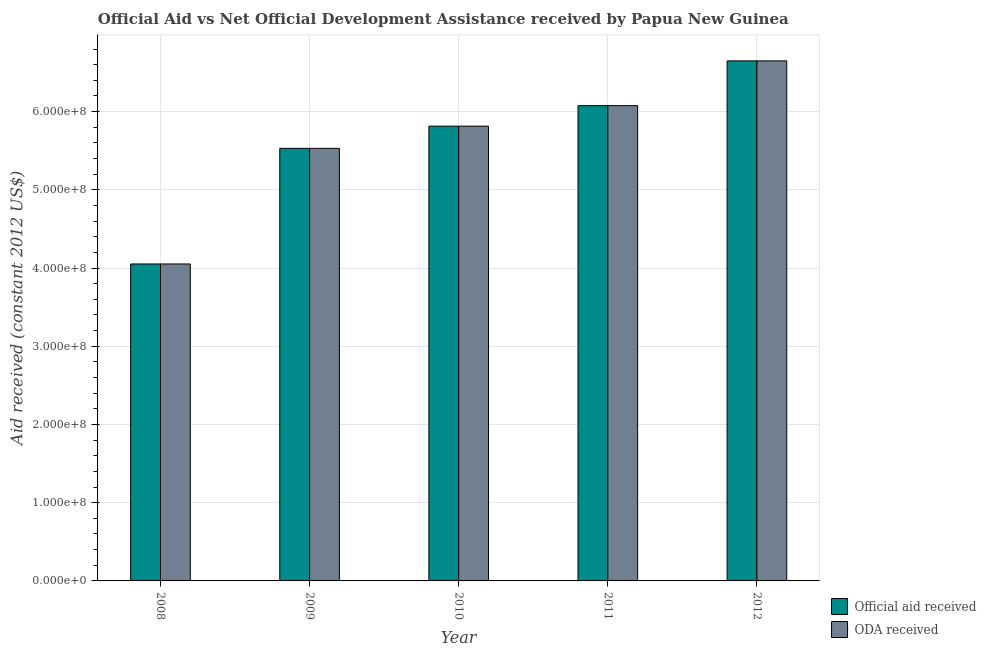Are the number of bars per tick equal to the number of legend labels?
Your answer should be very brief. Yes. Are the number of bars on each tick of the X-axis equal?
Provide a succinct answer. Yes. How many bars are there on the 1st tick from the left?
Your answer should be very brief. 2. How many bars are there on the 4th tick from the right?
Offer a very short reply. 2. What is the official aid received in 2008?
Give a very brief answer. 4.05e+08. Across all years, what is the maximum oda received?
Offer a terse response. 6.65e+08. Across all years, what is the minimum official aid received?
Make the answer very short. 4.05e+08. In which year was the oda received maximum?
Make the answer very short. 2012. What is the total official aid received in the graph?
Give a very brief answer. 2.81e+09. What is the difference between the oda received in 2008 and that in 2010?
Make the answer very short. -1.76e+08. What is the difference between the oda received in 2012 and the official aid received in 2009?
Provide a short and direct response. 1.12e+08. What is the average oda received per year?
Your response must be concise. 5.62e+08. In the year 2011, what is the difference between the oda received and official aid received?
Provide a short and direct response. 0. What is the ratio of the oda received in 2008 to that in 2009?
Provide a short and direct response. 0.73. Is the official aid received in 2009 less than that in 2010?
Give a very brief answer. Yes. Is the difference between the official aid received in 2008 and 2012 greater than the difference between the oda received in 2008 and 2012?
Offer a very short reply. No. What is the difference between the highest and the second highest official aid received?
Keep it short and to the point. 5.73e+07. What is the difference between the highest and the lowest oda received?
Offer a terse response. 2.60e+08. In how many years, is the oda received greater than the average oda received taken over all years?
Your answer should be very brief. 3. Is the sum of the official aid received in 2011 and 2012 greater than the maximum oda received across all years?
Ensure brevity in your answer.  Yes. What does the 2nd bar from the left in 2010 represents?
Offer a very short reply. ODA received. What does the 1st bar from the right in 2012 represents?
Make the answer very short. ODA received. Are all the bars in the graph horizontal?
Your answer should be compact. No. How many years are there in the graph?
Ensure brevity in your answer.  5. Are the values on the major ticks of Y-axis written in scientific E-notation?
Offer a terse response. Yes. Does the graph contain any zero values?
Make the answer very short. No. What is the title of the graph?
Your answer should be compact. Official Aid vs Net Official Development Assistance received by Papua New Guinea . What is the label or title of the Y-axis?
Your response must be concise. Aid received (constant 2012 US$). What is the Aid received (constant 2012 US$) of Official aid received in 2008?
Your answer should be compact. 4.05e+08. What is the Aid received (constant 2012 US$) in ODA received in 2008?
Offer a very short reply. 4.05e+08. What is the Aid received (constant 2012 US$) in Official aid received in 2009?
Your answer should be compact. 5.53e+08. What is the Aid received (constant 2012 US$) in ODA received in 2009?
Keep it short and to the point. 5.53e+08. What is the Aid received (constant 2012 US$) of Official aid received in 2010?
Your answer should be compact. 5.81e+08. What is the Aid received (constant 2012 US$) of ODA received in 2010?
Your response must be concise. 5.81e+08. What is the Aid received (constant 2012 US$) in Official aid received in 2011?
Your answer should be very brief. 6.08e+08. What is the Aid received (constant 2012 US$) of ODA received in 2011?
Your answer should be compact. 6.08e+08. What is the Aid received (constant 2012 US$) in Official aid received in 2012?
Ensure brevity in your answer.  6.65e+08. What is the Aid received (constant 2012 US$) of ODA received in 2012?
Keep it short and to the point. 6.65e+08. Across all years, what is the maximum Aid received (constant 2012 US$) in Official aid received?
Your answer should be compact. 6.65e+08. Across all years, what is the maximum Aid received (constant 2012 US$) of ODA received?
Give a very brief answer. 6.65e+08. Across all years, what is the minimum Aid received (constant 2012 US$) of Official aid received?
Provide a short and direct response. 4.05e+08. Across all years, what is the minimum Aid received (constant 2012 US$) in ODA received?
Ensure brevity in your answer.  4.05e+08. What is the total Aid received (constant 2012 US$) of Official aid received in the graph?
Ensure brevity in your answer.  2.81e+09. What is the total Aid received (constant 2012 US$) of ODA received in the graph?
Provide a short and direct response. 2.81e+09. What is the difference between the Aid received (constant 2012 US$) in Official aid received in 2008 and that in 2009?
Ensure brevity in your answer.  -1.48e+08. What is the difference between the Aid received (constant 2012 US$) of ODA received in 2008 and that in 2009?
Provide a succinct answer. -1.48e+08. What is the difference between the Aid received (constant 2012 US$) in Official aid received in 2008 and that in 2010?
Your answer should be very brief. -1.76e+08. What is the difference between the Aid received (constant 2012 US$) of ODA received in 2008 and that in 2010?
Keep it short and to the point. -1.76e+08. What is the difference between the Aid received (constant 2012 US$) in Official aid received in 2008 and that in 2011?
Ensure brevity in your answer.  -2.02e+08. What is the difference between the Aid received (constant 2012 US$) in ODA received in 2008 and that in 2011?
Provide a short and direct response. -2.02e+08. What is the difference between the Aid received (constant 2012 US$) of Official aid received in 2008 and that in 2012?
Make the answer very short. -2.60e+08. What is the difference between the Aid received (constant 2012 US$) in ODA received in 2008 and that in 2012?
Your answer should be compact. -2.60e+08. What is the difference between the Aid received (constant 2012 US$) of Official aid received in 2009 and that in 2010?
Offer a very short reply. -2.84e+07. What is the difference between the Aid received (constant 2012 US$) of ODA received in 2009 and that in 2010?
Provide a short and direct response. -2.84e+07. What is the difference between the Aid received (constant 2012 US$) of Official aid received in 2009 and that in 2011?
Offer a very short reply. -5.46e+07. What is the difference between the Aid received (constant 2012 US$) of ODA received in 2009 and that in 2011?
Ensure brevity in your answer.  -5.46e+07. What is the difference between the Aid received (constant 2012 US$) in Official aid received in 2009 and that in 2012?
Give a very brief answer. -1.12e+08. What is the difference between the Aid received (constant 2012 US$) in ODA received in 2009 and that in 2012?
Your response must be concise. -1.12e+08. What is the difference between the Aid received (constant 2012 US$) in Official aid received in 2010 and that in 2011?
Offer a very short reply. -2.62e+07. What is the difference between the Aid received (constant 2012 US$) of ODA received in 2010 and that in 2011?
Offer a terse response. -2.62e+07. What is the difference between the Aid received (constant 2012 US$) in Official aid received in 2010 and that in 2012?
Keep it short and to the point. -8.34e+07. What is the difference between the Aid received (constant 2012 US$) of ODA received in 2010 and that in 2012?
Your answer should be very brief. -8.34e+07. What is the difference between the Aid received (constant 2012 US$) of Official aid received in 2011 and that in 2012?
Offer a very short reply. -5.73e+07. What is the difference between the Aid received (constant 2012 US$) of ODA received in 2011 and that in 2012?
Give a very brief answer. -5.73e+07. What is the difference between the Aid received (constant 2012 US$) in Official aid received in 2008 and the Aid received (constant 2012 US$) in ODA received in 2009?
Keep it short and to the point. -1.48e+08. What is the difference between the Aid received (constant 2012 US$) in Official aid received in 2008 and the Aid received (constant 2012 US$) in ODA received in 2010?
Give a very brief answer. -1.76e+08. What is the difference between the Aid received (constant 2012 US$) in Official aid received in 2008 and the Aid received (constant 2012 US$) in ODA received in 2011?
Give a very brief answer. -2.02e+08. What is the difference between the Aid received (constant 2012 US$) in Official aid received in 2008 and the Aid received (constant 2012 US$) in ODA received in 2012?
Give a very brief answer. -2.60e+08. What is the difference between the Aid received (constant 2012 US$) in Official aid received in 2009 and the Aid received (constant 2012 US$) in ODA received in 2010?
Provide a succinct answer. -2.84e+07. What is the difference between the Aid received (constant 2012 US$) in Official aid received in 2009 and the Aid received (constant 2012 US$) in ODA received in 2011?
Keep it short and to the point. -5.46e+07. What is the difference between the Aid received (constant 2012 US$) of Official aid received in 2009 and the Aid received (constant 2012 US$) of ODA received in 2012?
Your answer should be very brief. -1.12e+08. What is the difference between the Aid received (constant 2012 US$) in Official aid received in 2010 and the Aid received (constant 2012 US$) in ODA received in 2011?
Your answer should be compact. -2.62e+07. What is the difference between the Aid received (constant 2012 US$) of Official aid received in 2010 and the Aid received (constant 2012 US$) of ODA received in 2012?
Your response must be concise. -8.34e+07. What is the difference between the Aid received (constant 2012 US$) of Official aid received in 2011 and the Aid received (constant 2012 US$) of ODA received in 2012?
Your response must be concise. -5.73e+07. What is the average Aid received (constant 2012 US$) of Official aid received per year?
Offer a terse response. 5.62e+08. What is the average Aid received (constant 2012 US$) of ODA received per year?
Your answer should be compact. 5.62e+08. In the year 2008, what is the difference between the Aid received (constant 2012 US$) of Official aid received and Aid received (constant 2012 US$) of ODA received?
Provide a succinct answer. 0. In the year 2009, what is the difference between the Aid received (constant 2012 US$) in Official aid received and Aid received (constant 2012 US$) in ODA received?
Provide a succinct answer. 0. In the year 2010, what is the difference between the Aid received (constant 2012 US$) of Official aid received and Aid received (constant 2012 US$) of ODA received?
Make the answer very short. 0. What is the ratio of the Aid received (constant 2012 US$) in Official aid received in 2008 to that in 2009?
Give a very brief answer. 0.73. What is the ratio of the Aid received (constant 2012 US$) of ODA received in 2008 to that in 2009?
Provide a short and direct response. 0.73. What is the ratio of the Aid received (constant 2012 US$) of Official aid received in 2008 to that in 2010?
Your answer should be compact. 0.7. What is the ratio of the Aid received (constant 2012 US$) in ODA received in 2008 to that in 2010?
Ensure brevity in your answer.  0.7. What is the ratio of the Aid received (constant 2012 US$) in Official aid received in 2008 to that in 2011?
Provide a short and direct response. 0.67. What is the ratio of the Aid received (constant 2012 US$) of ODA received in 2008 to that in 2011?
Make the answer very short. 0.67. What is the ratio of the Aid received (constant 2012 US$) in Official aid received in 2008 to that in 2012?
Your response must be concise. 0.61. What is the ratio of the Aid received (constant 2012 US$) in ODA received in 2008 to that in 2012?
Provide a succinct answer. 0.61. What is the ratio of the Aid received (constant 2012 US$) in Official aid received in 2009 to that in 2010?
Provide a short and direct response. 0.95. What is the ratio of the Aid received (constant 2012 US$) of ODA received in 2009 to that in 2010?
Offer a terse response. 0.95. What is the ratio of the Aid received (constant 2012 US$) of Official aid received in 2009 to that in 2011?
Your response must be concise. 0.91. What is the ratio of the Aid received (constant 2012 US$) in ODA received in 2009 to that in 2011?
Provide a succinct answer. 0.91. What is the ratio of the Aid received (constant 2012 US$) in Official aid received in 2009 to that in 2012?
Your answer should be very brief. 0.83. What is the ratio of the Aid received (constant 2012 US$) in ODA received in 2009 to that in 2012?
Make the answer very short. 0.83. What is the ratio of the Aid received (constant 2012 US$) of Official aid received in 2010 to that in 2011?
Give a very brief answer. 0.96. What is the ratio of the Aid received (constant 2012 US$) in ODA received in 2010 to that in 2011?
Give a very brief answer. 0.96. What is the ratio of the Aid received (constant 2012 US$) of Official aid received in 2010 to that in 2012?
Provide a short and direct response. 0.87. What is the ratio of the Aid received (constant 2012 US$) in ODA received in 2010 to that in 2012?
Offer a terse response. 0.87. What is the ratio of the Aid received (constant 2012 US$) in Official aid received in 2011 to that in 2012?
Your response must be concise. 0.91. What is the ratio of the Aid received (constant 2012 US$) in ODA received in 2011 to that in 2012?
Provide a short and direct response. 0.91. What is the difference between the highest and the second highest Aid received (constant 2012 US$) of Official aid received?
Your answer should be compact. 5.73e+07. What is the difference between the highest and the second highest Aid received (constant 2012 US$) of ODA received?
Provide a succinct answer. 5.73e+07. What is the difference between the highest and the lowest Aid received (constant 2012 US$) in Official aid received?
Provide a succinct answer. 2.60e+08. What is the difference between the highest and the lowest Aid received (constant 2012 US$) of ODA received?
Provide a succinct answer. 2.60e+08. 